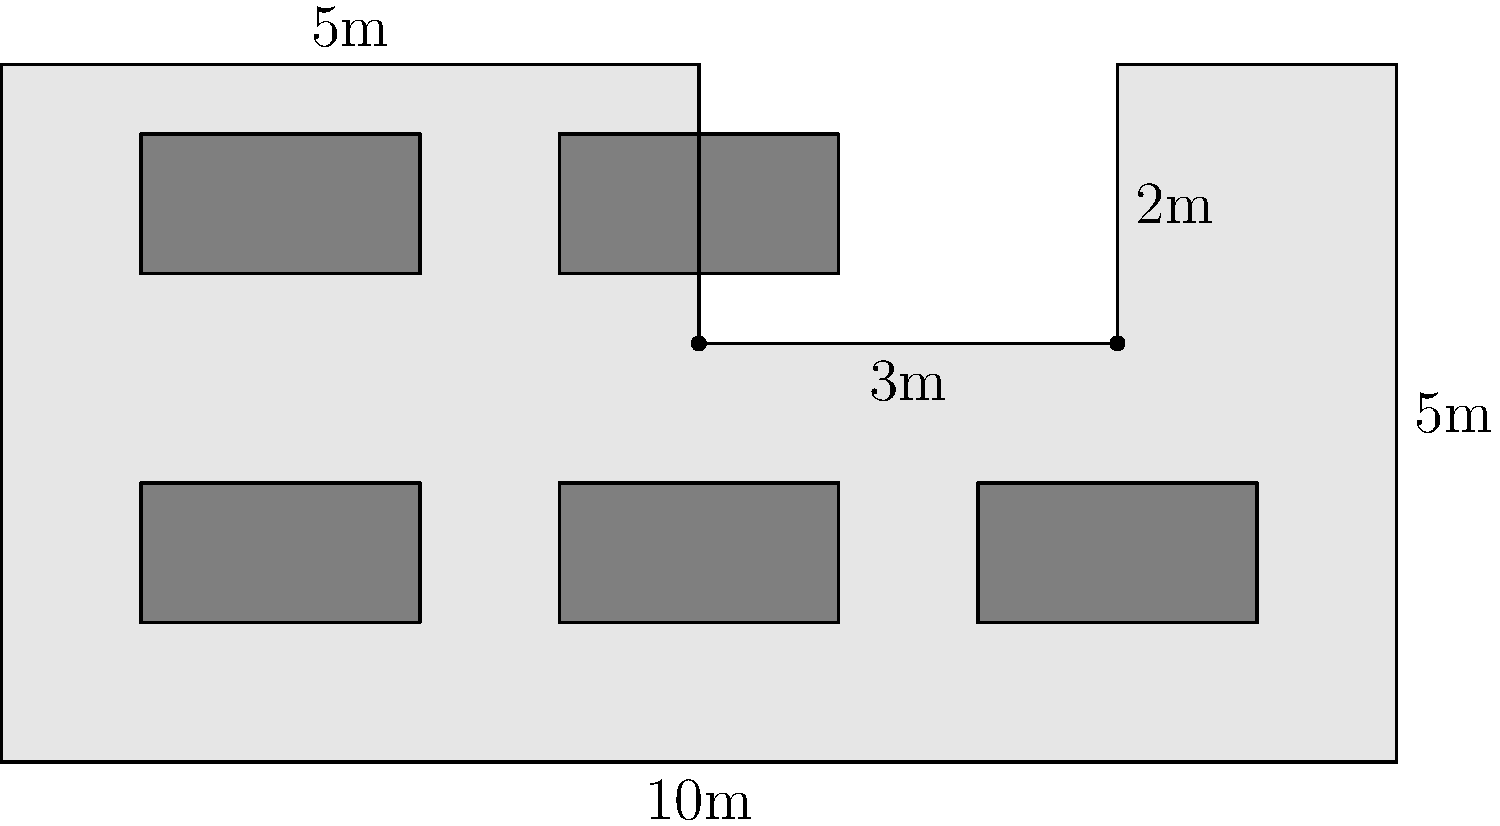Calculate the total area of the trading floor layout shown in the diagram. The floor has an irregular shape with dimensions as indicated. Each trading desk (represented by gray rectangles) measures 2m x 1m. What is the total available floor space after subtracting the area occupied by the trading desks? To solve this problem, we'll follow these steps:

1. Calculate the total area of the trading floor:
   - The floor can be divided into two rectangles: 10m x 3m and 8m x 2m
   - Area of larger rectangle: $10 \text{ m} \times 3 \text{ m} = 30 \text{ m}^2$
   - Area of smaller rectangle: $8 \text{ m} \times 2 \text{ m} = 16 \text{ m}^2$
   - Total floor area: $30 \text{ m}^2 + 16 \text{ m}^2 = 46 \text{ m}^2$

2. Calculate the area occupied by trading desks:
   - Each desk measures 2m x 1m, so its area is $2 \text{ m} \times 1 \text{ m} = 2 \text{ m}^2$
   - There are 5 desks in total
   - Total area occupied by desks: $5 \times 2 \text{ m}^2 = 10 \text{ m}^2$

3. Calculate the available floor space:
   - Available space = Total floor area - Area occupied by desks
   - Available space = $46 \text{ m}^2 - 10 \text{ m}^2 = 36 \text{ m}^2$

Therefore, the total available floor space after subtracting the area occupied by the trading desks is 36 m².
Answer: 36 m² 